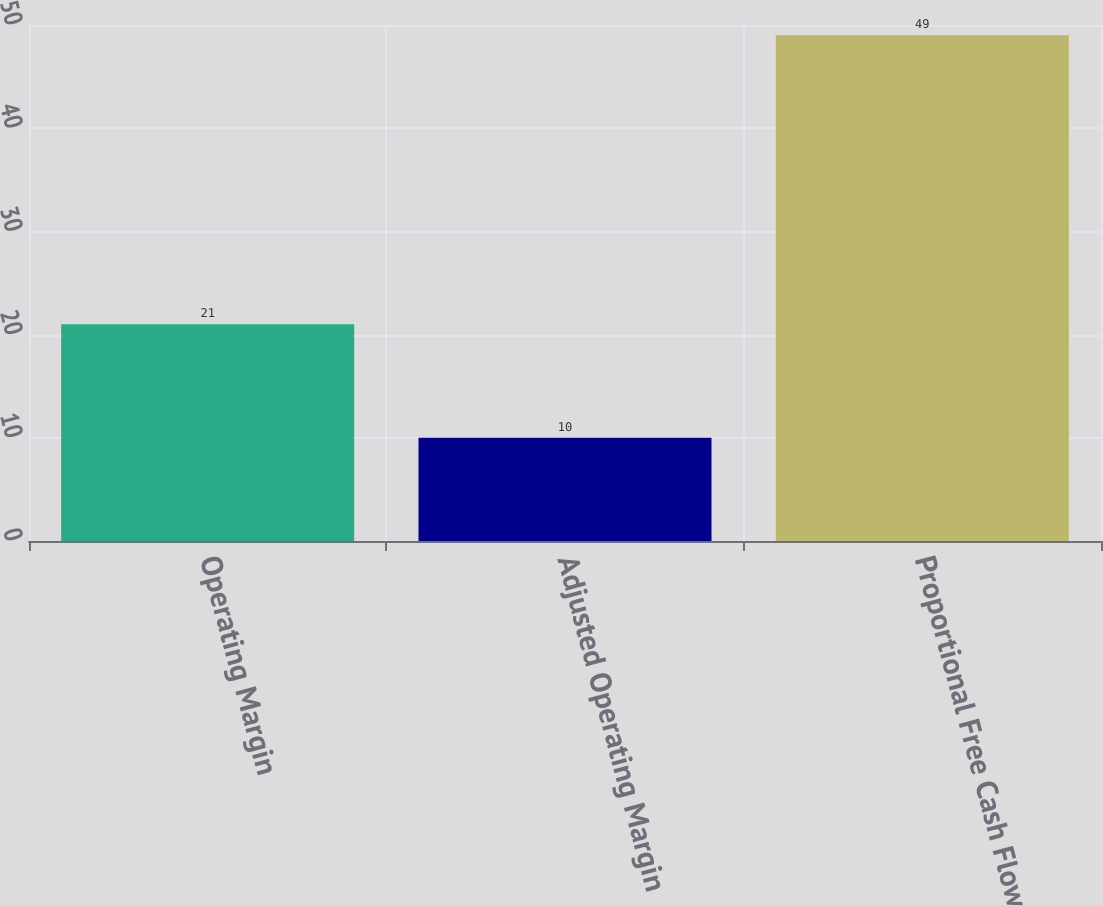<chart> <loc_0><loc_0><loc_500><loc_500><bar_chart><fcel>Operating Margin<fcel>Adjusted Operating Margin<fcel>Proportional Free Cash Flow<nl><fcel>21<fcel>10<fcel>49<nl></chart> 